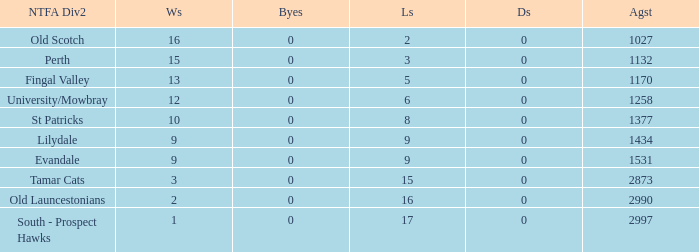What is the lowest number of draws of the team with 9 wins and less than 0 byes? None. 